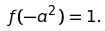Convert formula to latex. <formula><loc_0><loc_0><loc_500><loc_500>f ( - a ^ { 2 } ) = 1 .</formula> 